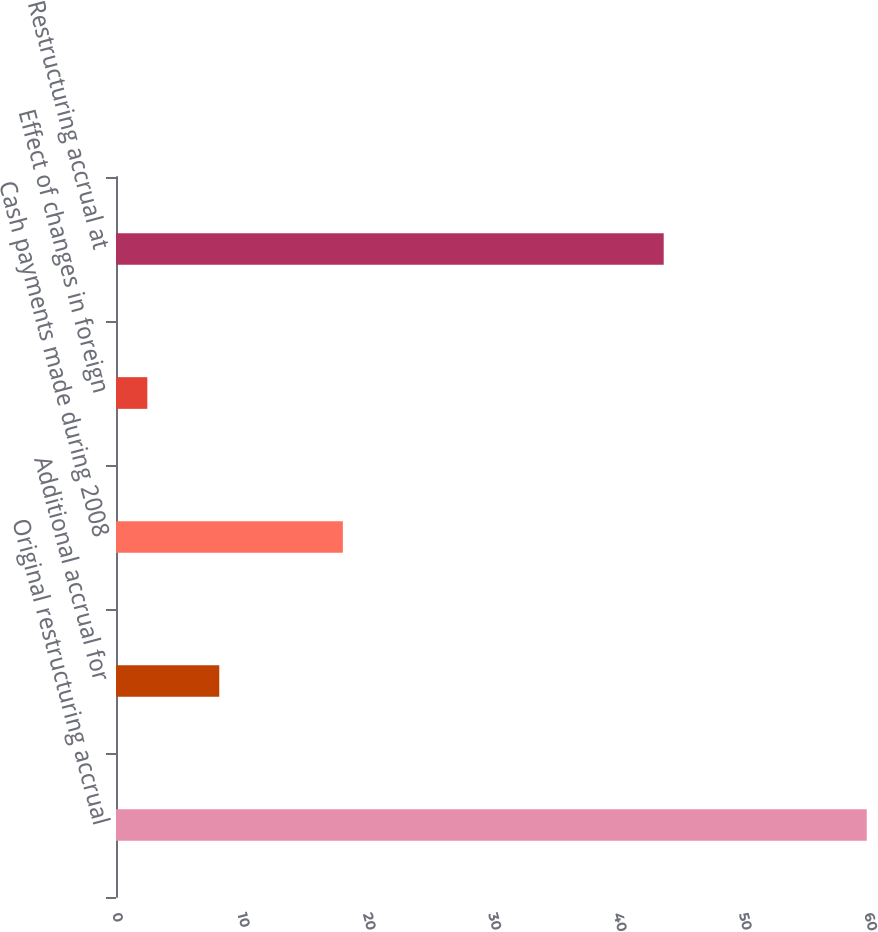Convert chart to OTSL. <chart><loc_0><loc_0><loc_500><loc_500><bar_chart><fcel>Original restructuring accrual<fcel>Additional accrual for<fcel>Cash payments made during 2008<fcel>Effect of changes in foreign<fcel>Restructuring accrual at<nl><fcel>59.9<fcel>8.24<fcel>18.1<fcel>2.5<fcel>43.7<nl></chart> 